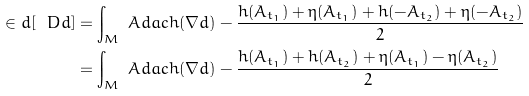Convert formula to latex. <formula><loc_0><loc_0><loc_500><loc_500>\in d [ \ D d ] & = \int _ { M } \ A d a c h ( \nabla d ) - \frac { h ( A _ { t _ { 1 } } ) + \eta ( A _ { t _ { 1 } } ) + h ( - A _ { t _ { 2 } } ) + \eta ( - A _ { t _ { 2 } } ) } { 2 } \\ & = \int _ { M } \ A d a c h ( \nabla d ) - \frac { h ( A _ { t _ { 1 } } ) + h ( A _ { t _ { 2 } } ) + \eta ( A _ { t _ { 1 } } ) - \eta ( A _ { t _ { 2 } } ) } { 2 }</formula> 